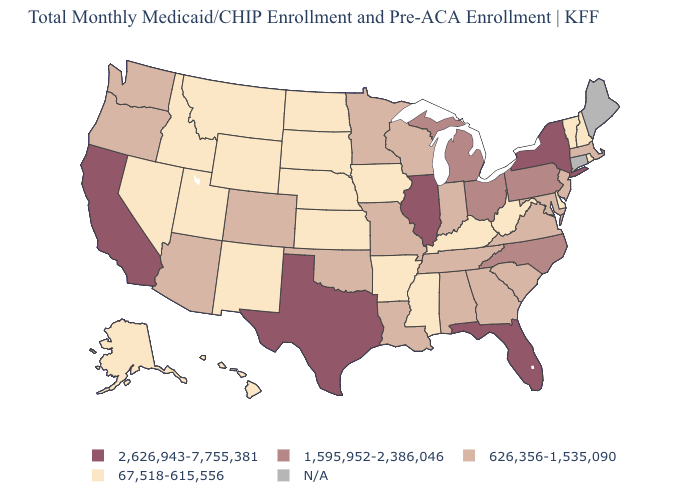Does the map have missing data?
Be succinct. Yes. Which states have the highest value in the USA?
Short answer required. California, Florida, Illinois, New York, Texas. Among the states that border Tennessee , does Arkansas have the lowest value?
Answer briefly. Yes. Name the states that have a value in the range 626,356-1,535,090?
Write a very short answer. Alabama, Arizona, Colorado, Georgia, Indiana, Louisiana, Maryland, Massachusetts, Minnesota, Missouri, New Jersey, Oklahoma, Oregon, South Carolina, Tennessee, Virginia, Washington, Wisconsin. Name the states that have a value in the range 626,356-1,535,090?
Answer briefly. Alabama, Arizona, Colorado, Georgia, Indiana, Louisiana, Maryland, Massachusetts, Minnesota, Missouri, New Jersey, Oklahoma, Oregon, South Carolina, Tennessee, Virginia, Washington, Wisconsin. Which states have the lowest value in the USA?
Concise answer only. Alaska, Arkansas, Delaware, Hawaii, Idaho, Iowa, Kansas, Kentucky, Mississippi, Montana, Nebraska, Nevada, New Hampshire, New Mexico, North Dakota, Rhode Island, South Dakota, Utah, Vermont, West Virginia, Wyoming. Name the states that have a value in the range N/A?
Short answer required. Connecticut, Maine. Name the states that have a value in the range 1,595,952-2,386,046?
Quick response, please. Michigan, North Carolina, Ohio, Pennsylvania. Does the first symbol in the legend represent the smallest category?
Be succinct. No. Name the states that have a value in the range 626,356-1,535,090?
Concise answer only. Alabama, Arizona, Colorado, Georgia, Indiana, Louisiana, Maryland, Massachusetts, Minnesota, Missouri, New Jersey, Oklahoma, Oregon, South Carolina, Tennessee, Virginia, Washington, Wisconsin. Among the states that border Pennsylvania , does Delaware have the lowest value?
Short answer required. Yes. Name the states that have a value in the range 67,518-615,556?
Short answer required. Alaska, Arkansas, Delaware, Hawaii, Idaho, Iowa, Kansas, Kentucky, Mississippi, Montana, Nebraska, Nevada, New Hampshire, New Mexico, North Dakota, Rhode Island, South Dakota, Utah, Vermont, West Virginia, Wyoming. Is the legend a continuous bar?
Write a very short answer. No. 